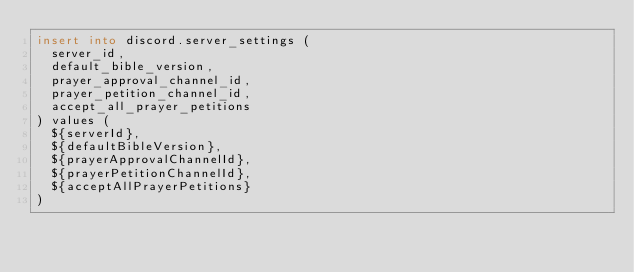<code> <loc_0><loc_0><loc_500><loc_500><_SQL_>insert into discord.server_settings (
  server_id,
  default_bible_version,
  prayer_approval_channel_id,
  prayer_petition_channel_id,
  accept_all_prayer_petitions
) values (
  ${serverId},
  ${defaultBibleVersion},
  ${prayerApprovalChannelId},
  ${prayerPetitionChannelId},
  ${acceptAllPrayerPetitions}
)
</code> 